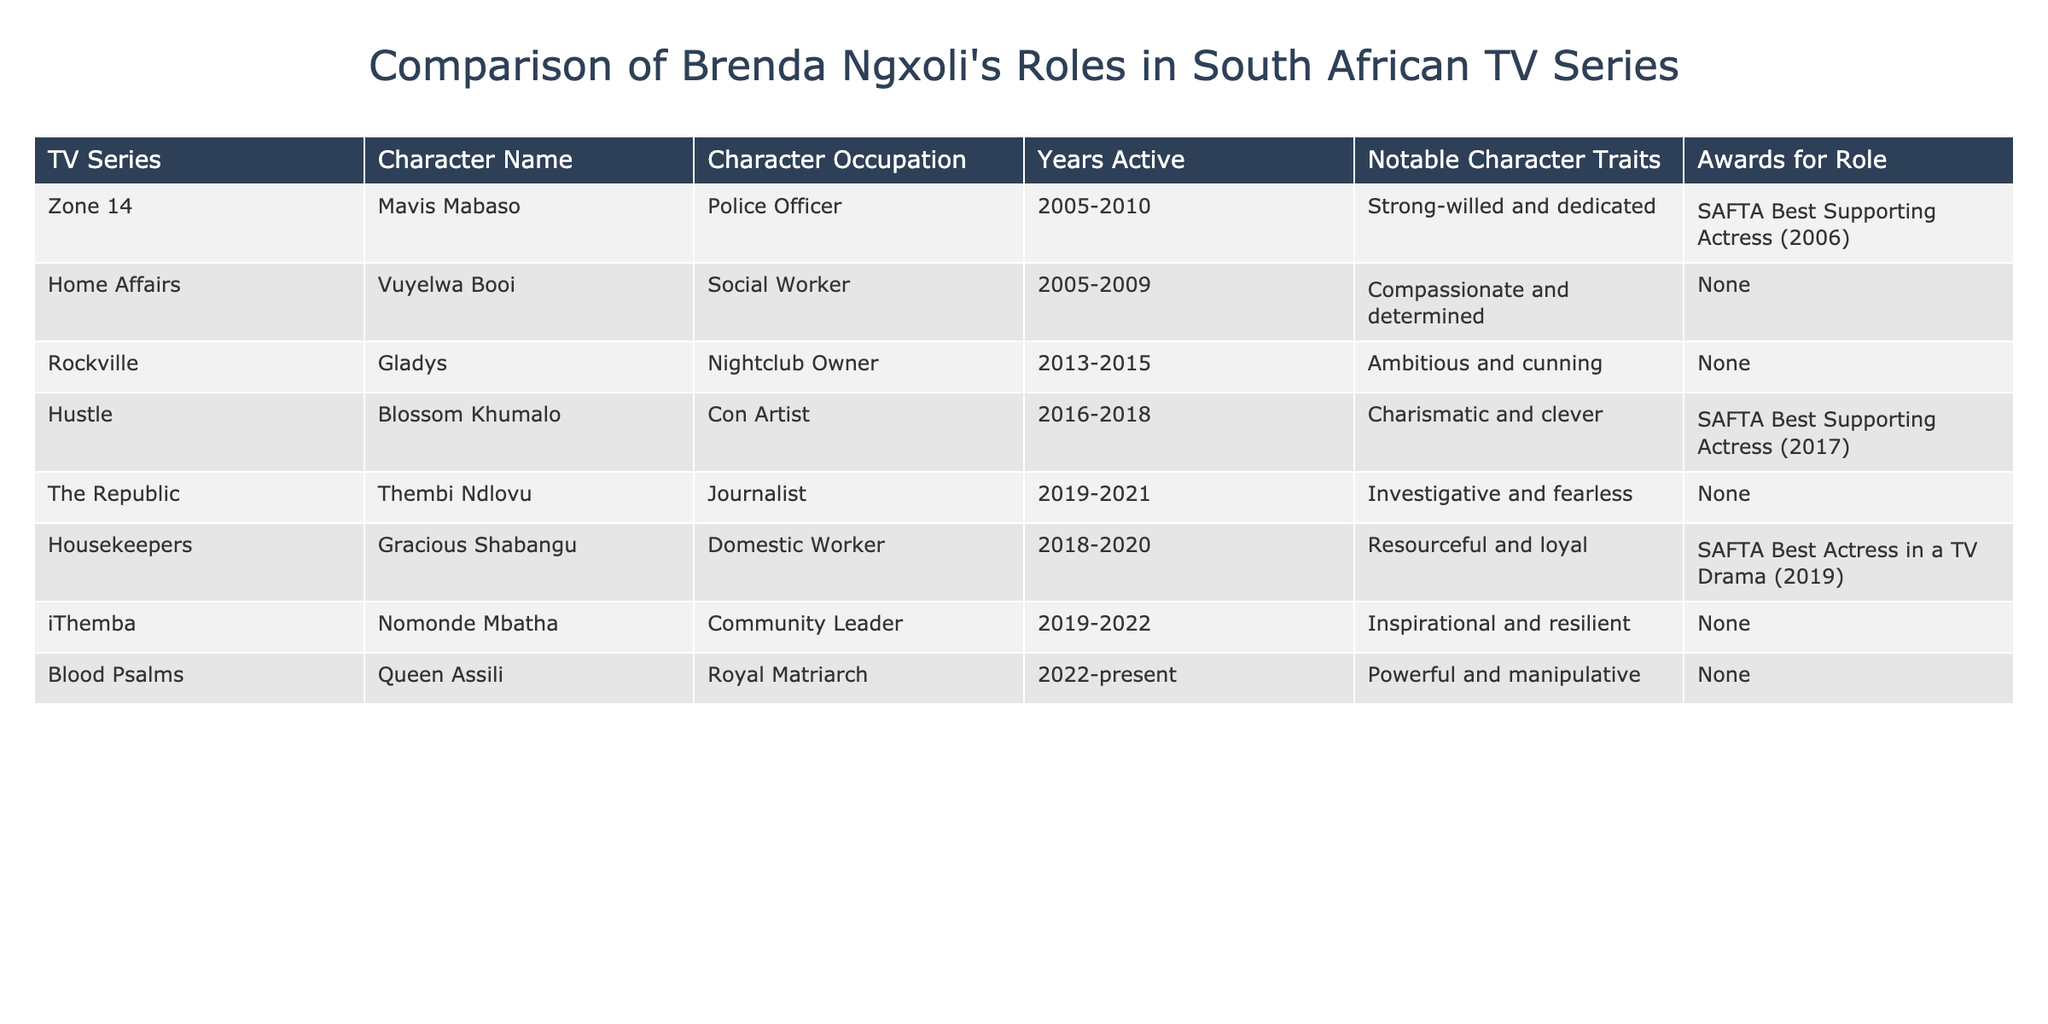What character did Brenda Ngxoli portray in 'Rockville'? The table indicates that Brenda Ngxoli played the character named Gladys in the TV series 'Rockville'.
Answer: Gladys Which role won Brenda Ngxoli a SAFTA award and in what year? According to the table, Brenda Ngxoli won the SAFTA Best Supporting Actress award in 2017 for her role as Blossom Khumalo in the series 'Hustle'.
Answer: Blossom Khumalo, 2017 How many TV series did Brenda Ngxoli play a character in between 2005 and 2022? The table lists a total of six different TV series where Brenda Ngxoli had a role between 2005 and 2022: 'Zone 14', 'Home Affairs', 'Rockville', 'Hustle', 'The Republic', and 'iThemba'.
Answer: Six Does Brenda Ngxoli's character in 'Home Affairs' have any notable character traits mentioned? The table shows that the character Vuyelwa Booi from 'Home Affairs' has the traits “Compassionate and determined,” indicating that yes, she has notable traits.
Answer: Yes Which occupations have Brenda Ngxoli's characters held across different series, and are there any overlaps? The table lists a variety of occupations: Police Officer, Social Worker, Nightclub Owner, Con Artist, Journalist, Domestic Worker, Community Leader, and Royal Matriarch. No roles have overlapping occupations among the series.
Answer: No overlaps What is the total number of years Brenda Ngxoli was active in the series listed if we consider her time in each role? By calculating the active years from the data, we see 'Zone 14' (5 years), 'Home Affairs' (4 years), 'Rockville' (2 years), 'Hustle' (2 years), 'The Republic' (2 years), 'Housekeepers' (2 years), 'iThemba' (3 years), and 'Blood Psalms' (current, so at least 1 year). Summing these gives: 5 + 4 + 2 + 2 + 2 + 2 + 3 + 1 = 21 years.
Answer: 21 years In which series did Brenda Ngxoli portray a character with leadership qualities? In the table, the character Nomonde Mbatha in 'iThemba' is described as a Community Leader, indicating leadership qualities are present in this role.
Answer: iThemba Which character of Brenda Ngxoli has the least notable character traits listed? By checking the table, the characters from 'Rockville', 'The Republic', 'iThemba', and 'Blood Psalms' do not have any notable character traits listed. Among these, 'Rockville' is the earliest in the timeline.
Answer: Gladys (Rockville) 